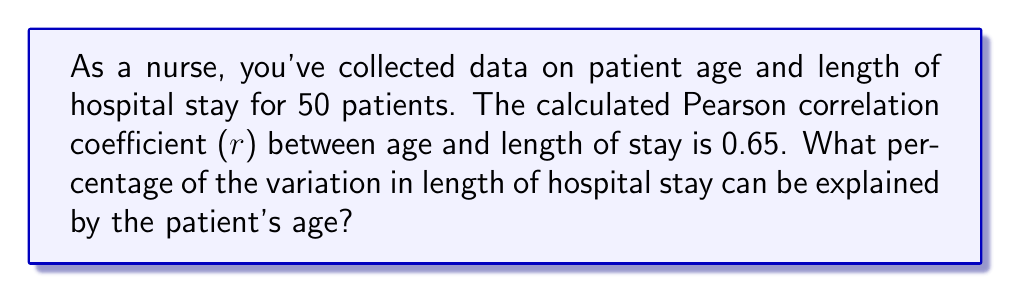Provide a solution to this math problem. To solve this problem, we need to understand the concept of the coefficient of determination, which is denoted as $R^2$.

1) The coefficient of determination ($R^2$) is the square of the Pearson correlation coefficient (r).

2) Given: $r = 0.65$

3) Calculate $R^2$:
   $R^2 = r^2 = (0.65)^2 = 0.4225$

4) $R^2$ represents the proportion of variance in the dependent variable (length of stay) that is predictable from the independent variable (age).

5) To express this as a percentage, multiply by 100:
   $0.4225 \times 100 = 42.25\%$

This means that 42.25% of the variation in length of hospital stay can be explained by the patient's age.
Answer: 42.25% 